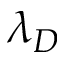<formula> <loc_0><loc_0><loc_500><loc_500>\lambda _ { D }</formula> 